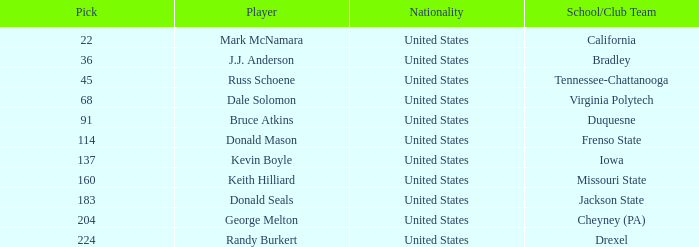In what earliest stage did donald mason possess a pick exceeding 114? None. 